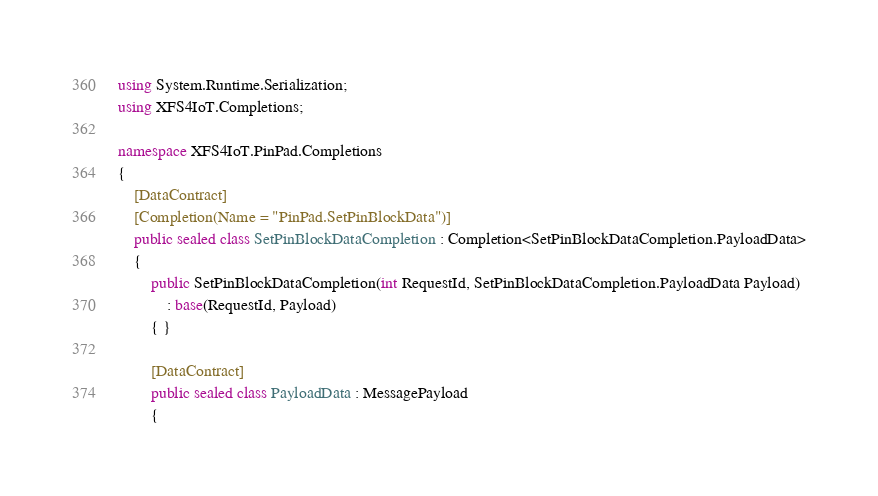Convert code to text. <code><loc_0><loc_0><loc_500><loc_500><_C#_>using System.Runtime.Serialization;
using XFS4IoT.Completions;

namespace XFS4IoT.PinPad.Completions
{
    [DataContract]
    [Completion(Name = "PinPad.SetPinBlockData")]
    public sealed class SetPinBlockDataCompletion : Completion<SetPinBlockDataCompletion.PayloadData>
    {
        public SetPinBlockDataCompletion(int RequestId, SetPinBlockDataCompletion.PayloadData Payload)
            : base(RequestId, Payload)
        { }

        [DataContract]
        public sealed class PayloadData : MessagePayload
        {
</code> 